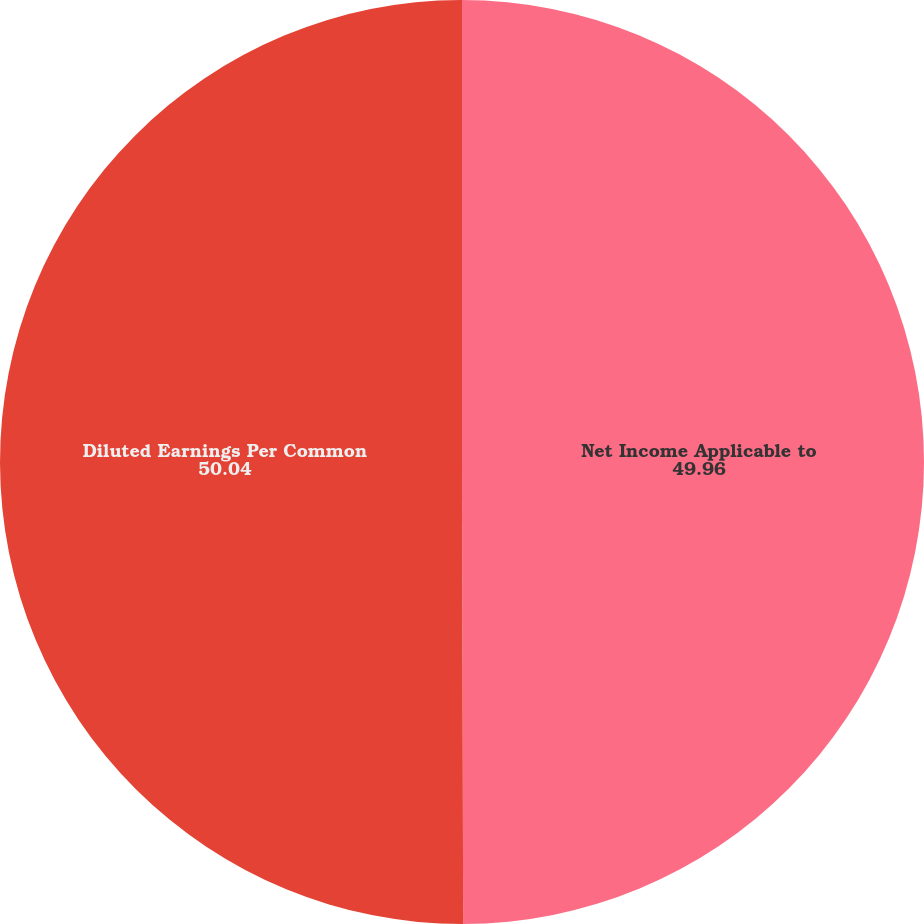Convert chart to OTSL. <chart><loc_0><loc_0><loc_500><loc_500><pie_chart><fcel>Net Income Applicable to<fcel>Diluted Earnings Per Common<nl><fcel>49.96%<fcel>50.04%<nl></chart> 